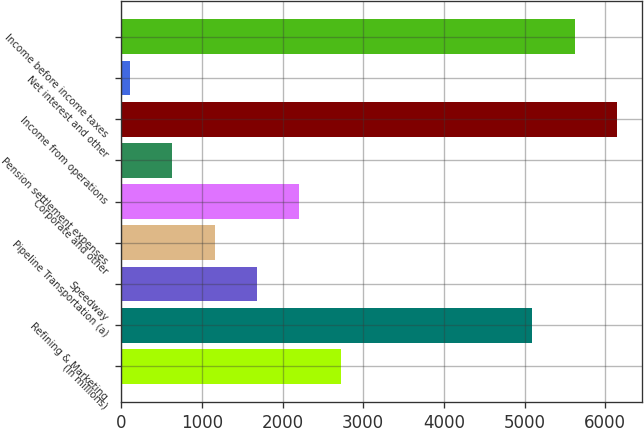Convert chart to OTSL. <chart><loc_0><loc_0><loc_500><loc_500><bar_chart><fcel>(In millions)<fcel>Refining & Marketing<fcel>Speedway<fcel>Pipeline Transportation (a)<fcel>Corporate and other<fcel>Pension settlement expenses<fcel>Income from operations<fcel>Net interest and other<fcel>Income before income taxes<nl><fcel>2728<fcel>5098<fcel>1680.4<fcel>1156.6<fcel>2204.2<fcel>632.8<fcel>6145.6<fcel>109<fcel>5621.8<nl></chart> 